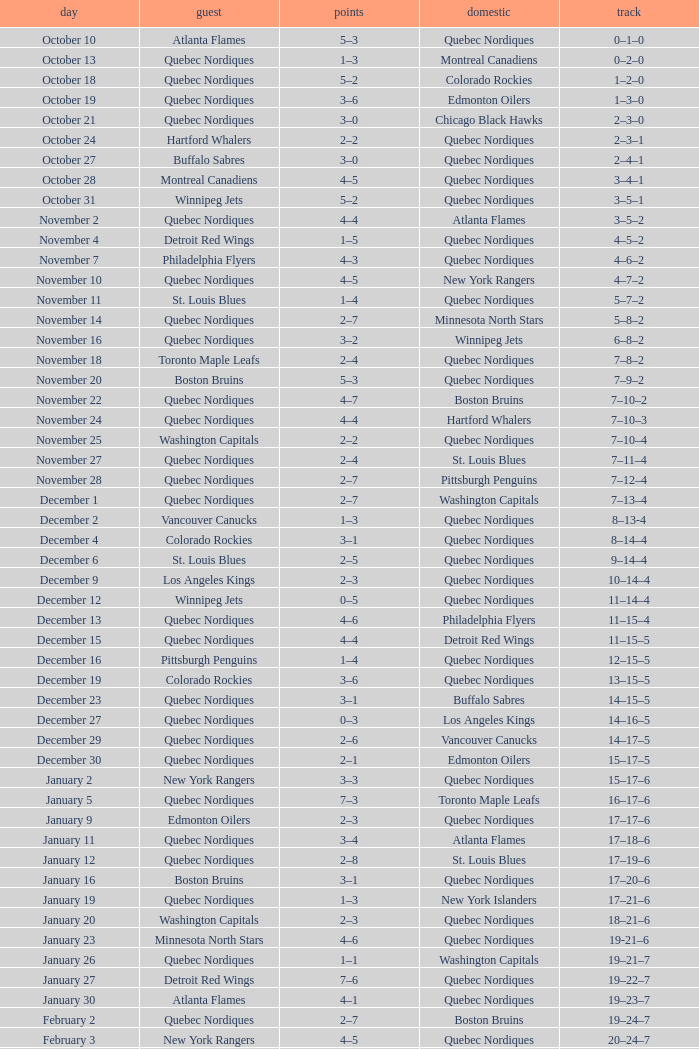Which Home has a Date of april 1? Quebec Nordiques. 